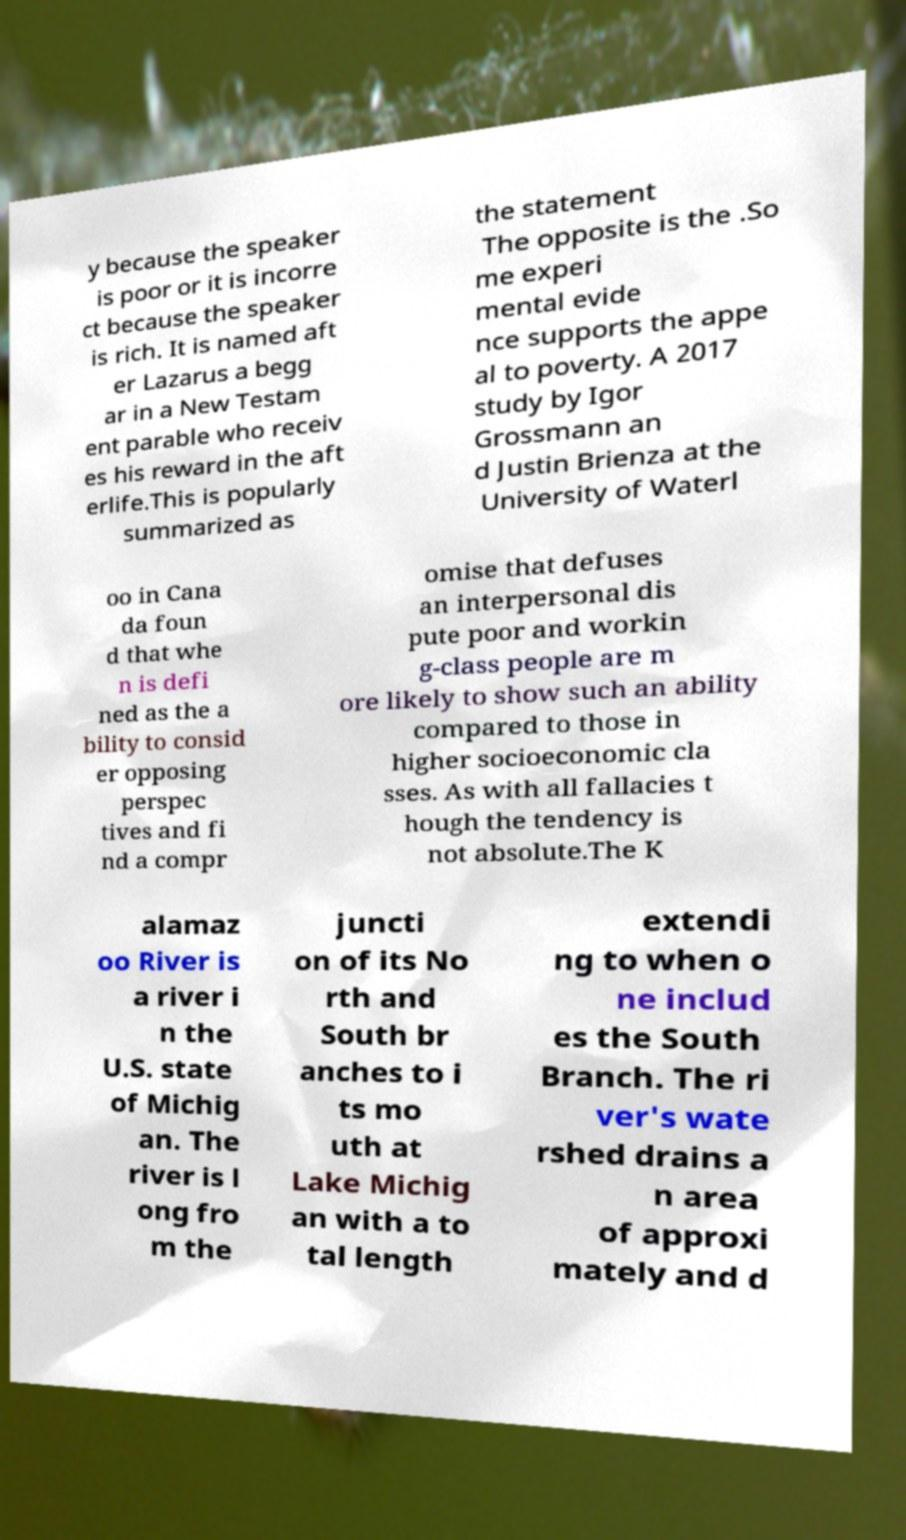Could you assist in decoding the text presented in this image and type it out clearly? y because the speaker is poor or it is incorre ct because the speaker is rich. It is named aft er Lazarus a begg ar in a New Testam ent parable who receiv es his reward in the aft erlife.This is popularly summarized as the statement The opposite is the .So me experi mental evide nce supports the appe al to poverty. A 2017 study by Igor Grossmann an d Justin Brienza at the University of Waterl oo in Cana da foun d that whe n is defi ned as the a bility to consid er opposing perspec tives and fi nd a compr omise that defuses an interpersonal dis pute poor and workin g-class people are m ore likely to show such an ability compared to those in higher socioeconomic cla sses. As with all fallacies t hough the tendency is not absolute.The K alamaz oo River is a river i n the U.S. state of Michig an. The river is l ong fro m the juncti on of its No rth and South br anches to i ts mo uth at Lake Michig an with a to tal length extendi ng to when o ne includ es the South Branch. The ri ver's wate rshed drains a n area of approxi mately and d 